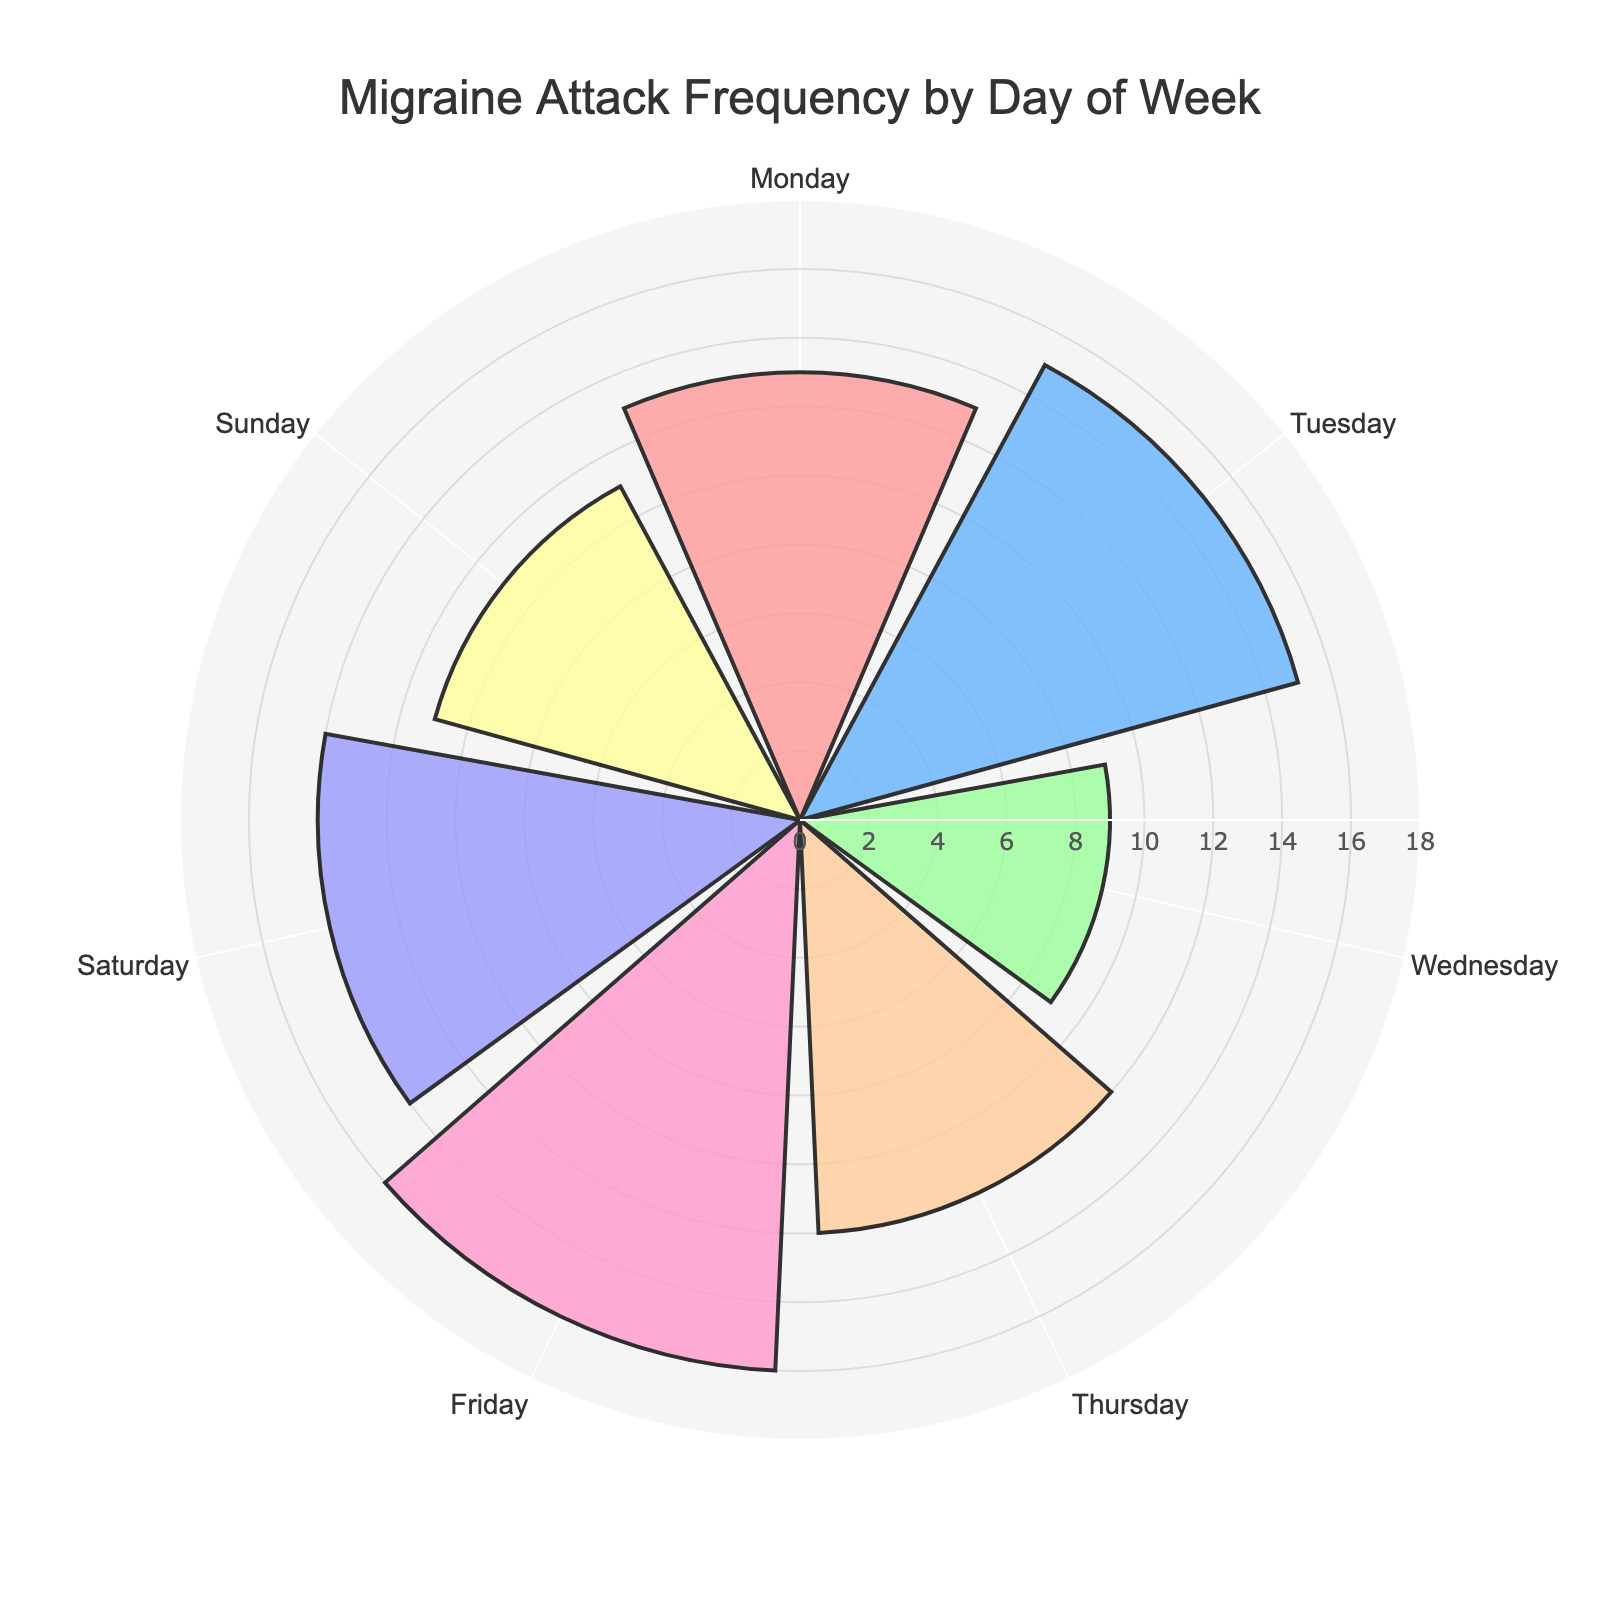What's the title of the chart? The title is prominently displayed at the top of the chart.
Answer: "Migraine Attack Frequency by Day of Week" Which day has the highest frequency of migraine attacks? By visually inspecting the lengths of the radial bars, the one representing Friday is the longest.
Answer: Friday How many attacks were recorded on Wednesday? Look for the radial bar labeled "Wednesday" and check its length against the radial axis scale.
Answer: 9 What's the total number of migraine attacks recorded for the entire week? Sum the frequencies for each day: 13 + 15 + 9 + 12 + 16 + 14 + 11 = 90.
Answer: 90 What's the average daily frequency of migraine attacks? Total number of attacks (90) divided by the number of days (7): 90 / 7 ≈ 12.86.
Answer: 12.86 Which day has fewer attacks, Tuesday or Sunday? Compare the lengths of the bars for Tuesday and Sunday. Tuesday has 15 attacks, and Sunday has 11.
Answer: Sunday How many more attacks are there on Friday compared to Monday? Subtract the frequency of Monday from Friday: 16 - 13 = 3.
Answer: 3 What is the range of the attack frequencies? Subtract the smallest frequency from the largest one: 16 - 9 = 7.
Answer: 7 Which days have attack frequencies above the weekly average? The weekly average is approximately 12.86. The days with frequencies above this average are Tuesday (15), Friday (16), and Saturday (14).
Answer: Tuesday, Friday, Saturday Are there any days with the same number of attacks? Scan through the radial bars and their respective values. None of the days have the same number of attacks.
Answer: No 